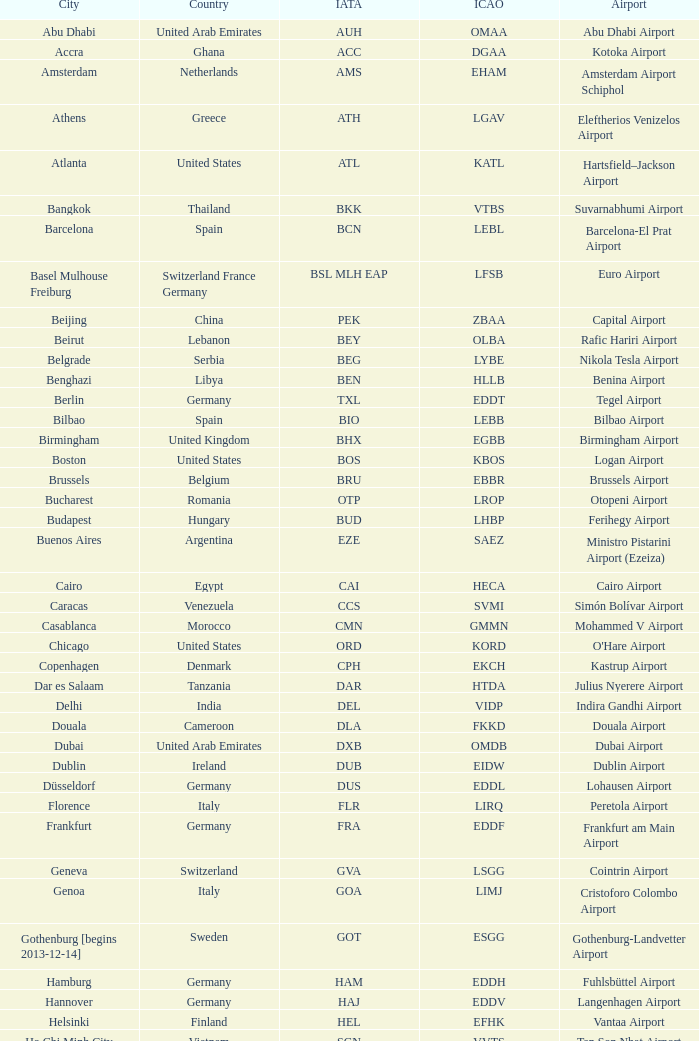What is the IATA of galeão airport? GIG. 